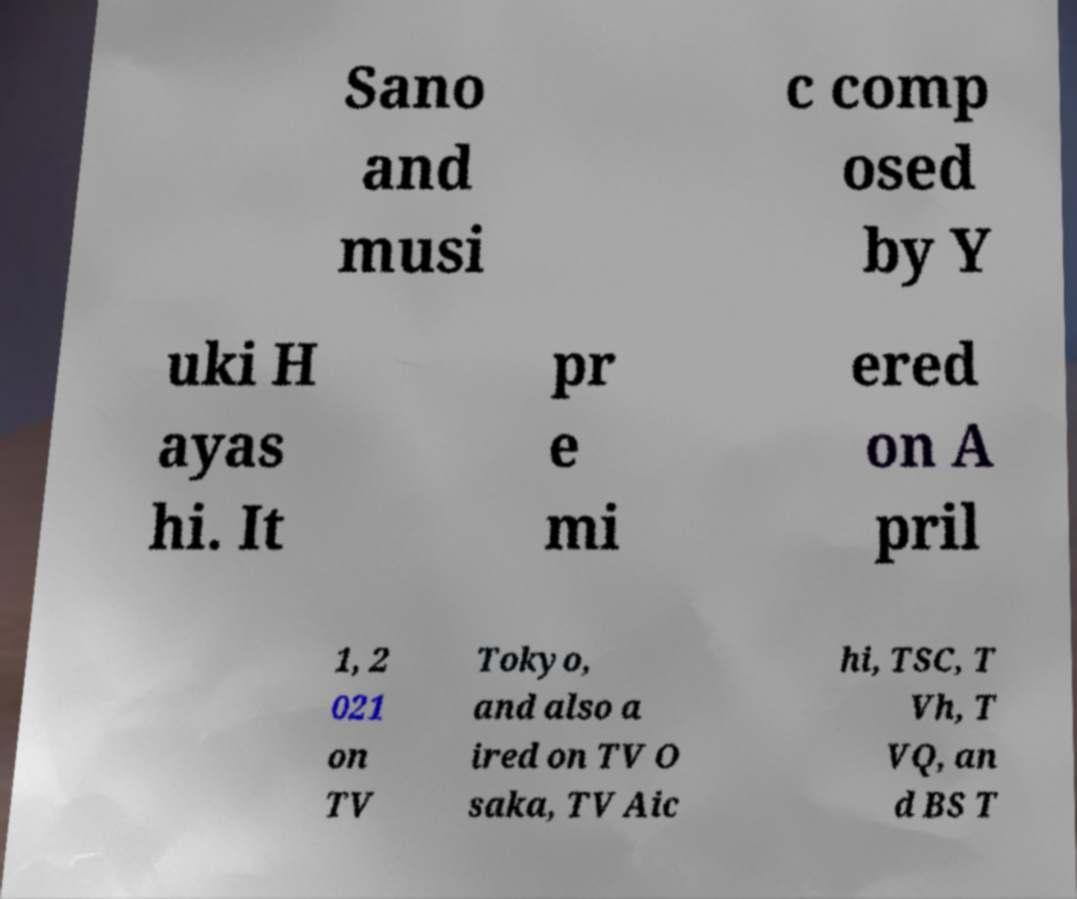Please read and relay the text visible in this image. What does it say? Sano and musi c comp osed by Y uki H ayas hi. It pr e mi ered on A pril 1, 2 021 on TV Tokyo, and also a ired on TV O saka, TV Aic hi, TSC, T Vh, T VQ, an d BS T 